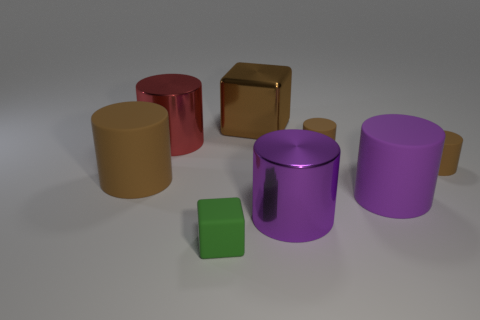Subtract all small rubber cylinders. How many cylinders are left? 4 Subtract all red cubes. How many purple cylinders are left? 2 Subtract all red cylinders. How many cylinders are left? 5 Add 1 rubber blocks. How many objects exist? 9 Subtract all yellow cylinders. Subtract all gray balls. How many cylinders are left? 6 Add 8 brown metallic cubes. How many brown metallic cubes exist? 9 Subtract 0 purple balls. How many objects are left? 8 Subtract all cylinders. How many objects are left? 2 Subtract all tiny red spheres. Subtract all brown matte things. How many objects are left? 5 Add 5 purple metallic cylinders. How many purple metallic cylinders are left? 6 